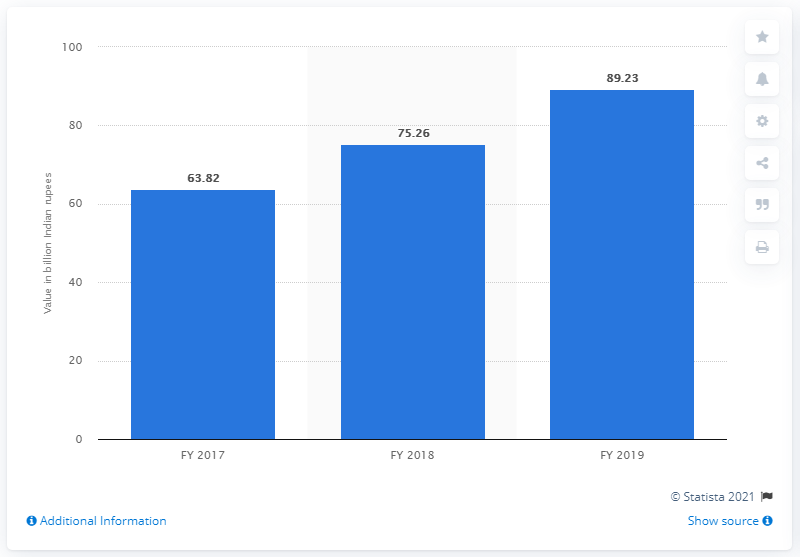List a handful of essential elements in this visual. At the end of fiscal year 2019, Vijaya Bank's gross non-performing assets were valued at 89.23. 